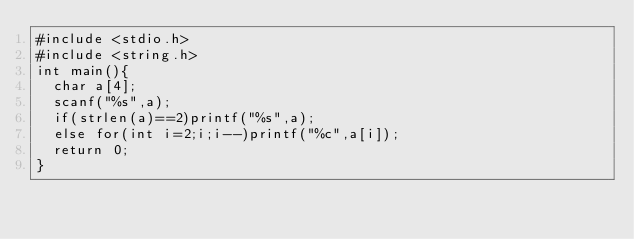<code> <loc_0><loc_0><loc_500><loc_500><_C_>#include <stdio.h>
#include <string.h>
int main(){
  char a[4];
  scanf("%s",a);
  if(strlen(a)==2)printf("%s",a);
  else for(int i=2;i;i--)printf("%c",a[i]);
  return 0;
}</code> 